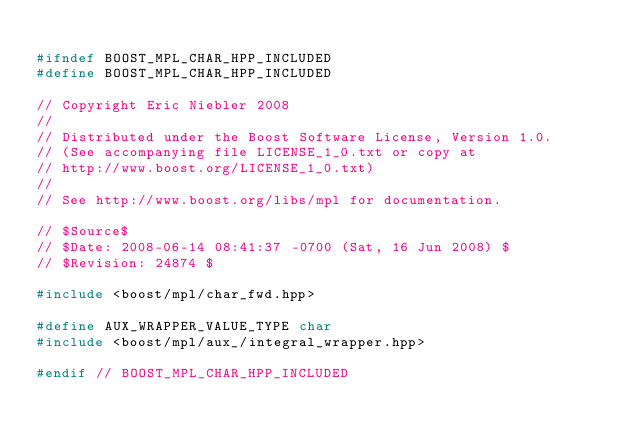Convert code to text. <code><loc_0><loc_0><loc_500><loc_500><_C++_>
#ifndef BOOST_MPL_CHAR_HPP_INCLUDED
#define BOOST_MPL_CHAR_HPP_INCLUDED

// Copyright Eric Niebler 2008
//
// Distributed under the Boost Software License, Version 1.0. 
// (See accompanying file LICENSE_1_0.txt or copy at 
// http://www.boost.org/LICENSE_1_0.txt)
//
// See http://www.boost.org/libs/mpl for documentation.

// $Source$
// $Date: 2008-06-14 08:41:37 -0700 (Sat, 16 Jun 2008) $
// $Revision: 24874 $

#include <boost/mpl/char_fwd.hpp>

#define AUX_WRAPPER_VALUE_TYPE char
#include <boost/mpl/aux_/integral_wrapper.hpp>

#endif // BOOST_MPL_CHAR_HPP_INCLUDED
</code> 